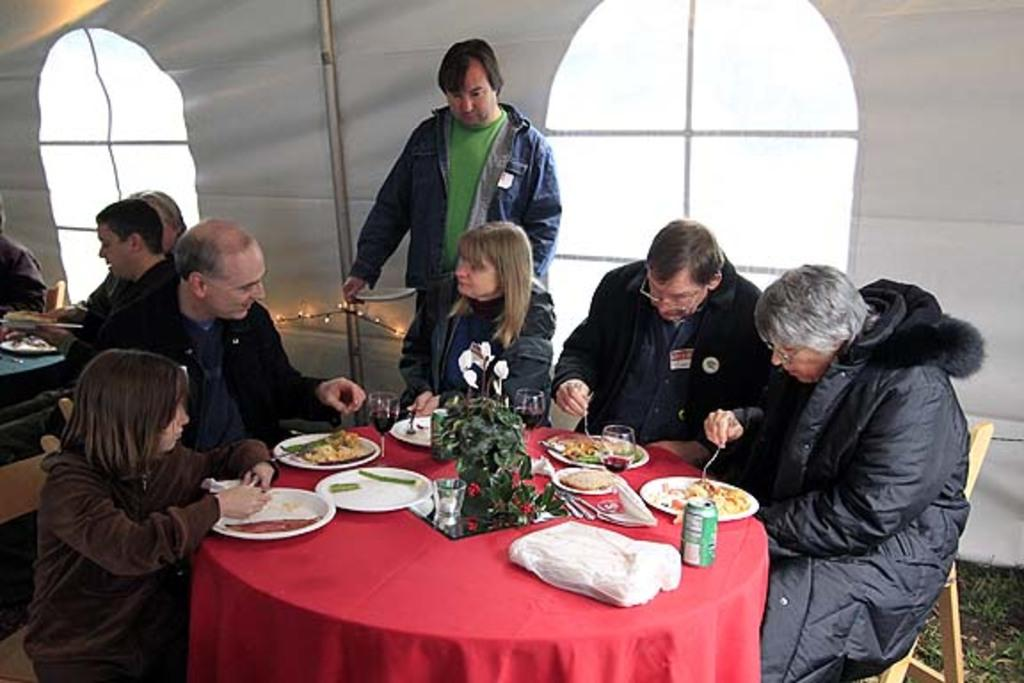What are the people in the image doing? The people in the image are sitting on chairs. What is the person standing holding? The person standing is holding a plate. What piece of furniture is present in the image? There is a table in the image. What items can be found on the table? There are plates, glasses, food, spoons, a plant, a tin, and a cloth on the table. What news is being discussed around the table in the image? There is no indication of any news being discussed in the image. Is there a sink visible in the image? No, there is no sink present in the image. 